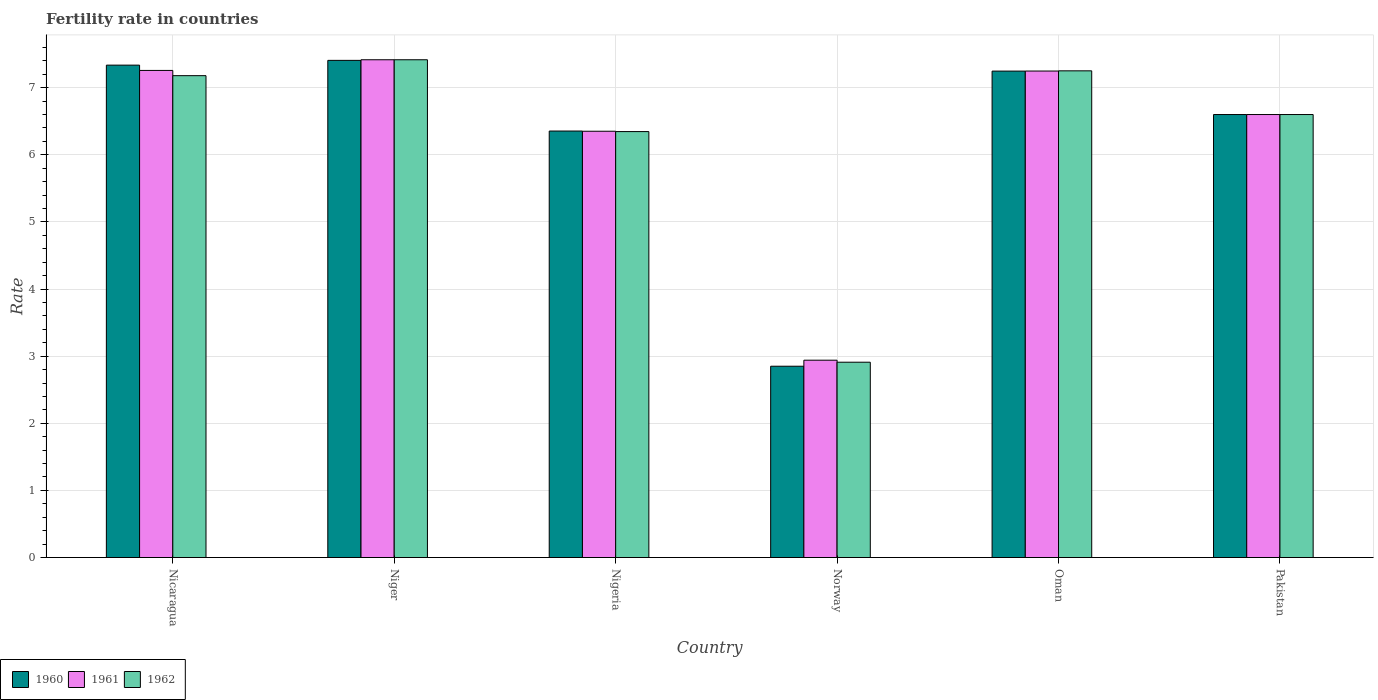How many groups of bars are there?
Make the answer very short. 6. Are the number of bars per tick equal to the number of legend labels?
Ensure brevity in your answer.  Yes. How many bars are there on the 2nd tick from the right?
Ensure brevity in your answer.  3. In how many cases, is the number of bars for a given country not equal to the number of legend labels?
Give a very brief answer. 0. What is the fertility rate in 1962 in Nigeria?
Your response must be concise. 6.35. Across all countries, what is the maximum fertility rate in 1962?
Provide a succinct answer. 7.42. Across all countries, what is the minimum fertility rate in 1961?
Provide a succinct answer. 2.94. In which country was the fertility rate in 1960 maximum?
Offer a very short reply. Niger. In which country was the fertility rate in 1960 minimum?
Your response must be concise. Norway. What is the total fertility rate in 1960 in the graph?
Your answer should be compact. 37.79. What is the difference between the fertility rate in 1961 in Niger and that in Pakistan?
Make the answer very short. 0.82. What is the difference between the fertility rate in 1961 in Norway and the fertility rate in 1960 in Oman?
Ensure brevity in your answer.  -4.31. What is the average fertility rate in 1960 per country?
Provide a succinct answer. 6.3. What is the difference between the fertility rate of/in 1960 and fertility rate of/in 1961 in Oman?
Make the answer very short. -0. In how many countries, is the fertility rate in 1961 greater than 5.6?
Provide a short and direct response. 5. What is the ratio of the fertility rate in 1961 in Norway to that in Oman?
Provide a short and direct response. 0.41. Is the difference between the fertility rate in 1960 in Nigeria and Pakistan greater than the difference between the fertility rate in 1961 in Nigeria and Pakistan?
Ensure brevity in your answer.  Yes. What is the difference between the highest and the second highest fertility rate in 1961?
Ensure brevity in your answer.  -0.01. What is the difference between the highest and the lowest fertility rate in 1961?
Give a very brief answer. 4.48. Is it the case that in every country, the sum of the fertility rate in 1960 and fertility rate in 1962 is greater than the fertility rate in 1961?
Make the answer very short. Yes. Are all the bars in the graph horizontal?
Your answer should be compact. No. What is the difference between two consecutive major ticks on the Y-axis?
Ensure brevity in your answer.  1. Are the values on the major ticks of Y-axis written in scientific E-notation?
Make the answer very short. No. Does the graph contain grids?
Offer a terse response. Yes. How many legend labels are there?
Your response must be concise. 3. How are the legend labels stacked?
Make the answer very short. Horizontal. What is the title of the graph?
Your response must be concise. Fertility rate in countries. What is the label or title of the X-axis?
Provide a succinct answer. Country. What is the label or title of the Y-axis?
Offer a very short reply. Rate. What is the Rate of 1960 in Nicaragua?
Provide a short and direct response. 7.34. What is the Rate in 1961 in Nicaragua?
Provide a short and direct response. 7.26. What is the Rate of 1962 in Nicaragua?
Provide a succinct answer. 7.18. What is the Rate of 1960 in Niger?
Your answer should be compact. 7.41. What is the Rate of 1961 in Niger?
Offer a very short reply. 7.42. What is the Rate in 1962 in Niger?
Give a very brief answer. 7.42. What is the Rate of 1960 in Nigeria?
Provide a short and direct response. 6.35. What is the Rate in 1961 in Nigeria?
Your answer should be very brief. 6.35. What is the Rate of 1962 in Nigeria?
Provide a succinct answer. 6.35. What is the Rate in 1960 in Norway?
Provide a short and direct response. 2.85. What is the Rate of 1961 in Norway?
Your answer should be very brief. 2.94. What is the Rate in 1962 in Norway?
Keep it short and to the point. 2.91. What is the Rate in 1960 in Oman?
Your answer should be very brief. 7.25. What is the Rate in 1961 in Oman?
Provide a short and direct response. 7.25. What is the Rate of 1962 in Oman?
Provide a succinct answer. 7.25. What is the Rate in 1960 in Pakistan?
Your response must be concise. 6.6. What is the Rate in 1961 in Pakistan?
Offer a very short reply. 6.6. Across all countries, what is the maximum Rate of 1960?
Give a very brief answer. 7.41. Across all countries, what is the maximum Rate of 1961?
Keep it short and to the point. 7.42. Across all countries, what is the maximum Rate in 1962?
Offer a very short reply. 7.42. Across all countries, what is the minimum Rate of 1960?
Provide a succinct answer. 2.85. Across all countries, what is the minimum Rate of 1961?
Ensure brevity in your answer.  2.94. Across all countries, what is the minimum Rate in 1962?
Give a very brief answer. 2.91. What is the total Rate of 1960 in the graph?
Offer a terse response. 37.79. What is the total Rate of 1961 in the graph?
Offer a very short reply. 37.81. What is the total Rate in 1962 in the graph?
Offer a terse response. 37.7. What is the difference between the Rate in 1960 in Nicaragua and that in Niger?
Your answer should be compact. -0.07. What is the difference between the Rate of 1961 in Nicaragua and that in Niger?
Keep it short and to the point. -0.16. What is the difference between the Rate in 1962 in Nicaragua and that in Niger?
Offer a terse response. -0.24. What is the difference between the Rate in 1960 in Nicaragua and that in Nigeria?
Keep it short and to the point. 0.98. What is the difference between the Rate in 1961 in Nicaragua and that in Nigeria?
Offer a very short reply. 0.91. What is the difference between the Rate in 1962 in Nicaragua and that in Nigeria?
Make the answer very short. 0.83. What is the difference between the Rate of 1960 in Nicaragua and that in Norway?
Ensure brevity in your answer.  4.49. What is the difference between the Rate in 1961 in Nicaragua and that in Norway?
Ensure brevity in your answer.  4.32. What is the difference between the Rate in 1962 in Nicaragua and that in Norway?
Your answer should be very brief. 4.27. What is the difference between the Rate of 1960 in Nicaragua and that in Oman?
Your answer should be compact. 0.09. What is the difference between the Rate of 1961 in Nicaragua and that in Oman?
Provide a succinct answer. 0.01. What is the difference between the Rate in 1962 in Nicaragua and that in Oman?
Your answer should be very brief. -0.07. What is the difference between the Rate in 1960 in Nicaragua and that in Pakistan?
Offer a terse response. 0.74. What is the difference between the Rate in 1961 in Nicaragua and that in Pakistan?
Your answer should be compact. 0.66. What is the difference between the Rate of 1962 in Nicaragua and that in Pakistan?
Your response must be concise. 0.58. What is the difference between the Rate in 1960 in Niger and that in Nigeria?
Offer a very short reply. 1.05. What is the difference between the Rate in 1961 in Niger and that in Nigeria?
Provide a short and direct response. 1.06. What is the difference between the Rate of 1962 in Niger and that in Nigeria?
Your answer should be very brief. 1.07. What is the difference between the Rate in 1960 in Niger and that in Norway?
Give a very brief answer. 4.56. What is the difference between the Rate in 1961 in Niger and that in Norway?
Provide a succinct answer. 4.48. What is the difference between the Rate of 1962 in Niger and that in Norway?
Provide a short and direct response. 4.51. What is the difference between the Rate in 1960 in Niger and that in Oman?
Your answer should be very brief. 0.16. What is the difference between the Rate of 1961 in Niger and that in Oman?
Offer a very short reply. 0.17. What is the difference between the Rate of 1962 in Niger and that in Oman?
Ensure brevity in your answer.  0.17. What is the difference between the Rate of 1960 in Niger and that in Pakistan?
Make the answer very short. 0.81. What is the difference between the Rate in 1961 in Niger and that in Pakistan?
Provide a succinct answer. 0.82. What is the difference between the Rate of 1962 in Niger and that in Pakistan?
Your answer should be very brief. 0.82. What is the difference between the Rate in 1960 in Nigeria and that in Norway?
Provide a succinct answer. 3.5. What is the difference between the Rate in 1961 in Nigeria and that in Norway?
Ensure brevity in your answer.  3.41. What is the difference between the Rate in 1962 in Nigeria and that in Norway?
Ensure brevity in your answer.  3.44. What is the difference between the Rate in 1960 in Nigeria and that in Oman?
Provide a short and direct response. -0.89. What is the difference between the Rate in 1961 in Nigeria and that in Oman?
Your response must be concise. -0.9. What is the difference between the Rate of 1962 in Nigeria and that in Oman?
Offer a terse response. -0.91. What is the difference between the Rate in 1960 in Nigeria and that in Pakistan?
Your answer should be compact. -0.25. What is the difference between the Rate of 1961 in Nigeria and that in Pakistan?
Make the answer very short. -0.25. What is the difference between the Rate of 1962 in Nigeria and that in Pakistan?
Your response must be concise. -0.25. What is the difference between the Rate in 1960 in Norway and that in Oman?
Ensure brevity in your answer.  -4.4. What is the difference between the Rate in 1961 in Norway and that in Oman?
Provide a succinct answer. -4.31. What is the difference between the Rate in 1962 in Norway and that in Oman?
Keep it short and to the point. -4.34. What is the difference between the Rate of 1960 in Norway and that in Pakistan?
Offer a terse response. -3.75. What is the difference between the Rate of 1961 in Norway and that in Pakistan?
Make the answer very short. -3.66. What is the difference between the Rate in 1962 in Norway and that in Pakistan?
Provide a short and direct response. -3.69. What is the difference between the Rate in 1960 in Oman and that in Pakistan?
Give a very brief answer. 0.65. What is the difference between the Rate in 1961 in Oman and that in Pakistan?
Ensure brevity in your answer.  0.65. What is the difference between the Rate of 1962 in Oman and that in Pakistan?
Provide a succinct answer. 0.65. What is the difference between the Rate in 1960 in Nicaragua and the Rate in 1961 in Niger?
Offer a very short reply. -0.08. What is the difference between the Rate of 1960 in Nicaragua and the Rate of 1962 in Niger?
Your answer should be very brief. -0.08. What is the difference between the Rate of 1961 in Nicaragua and the Rate of 1962 in Niger?
Provide a succinct answer. -0.16. What is the difference between the Rate of 1960 in Nicaragua and the Rate of 1961 in Nigeria?
Keep it short and to the point. 0.98. What is the difference between the Rate in 1961 in Nicaragua and the Rate in 1962 in Nigeria?
Give a very brief answer. 0.91. What is the difference between the Rate in 1960 in Nicaragua and the Rate in 1961 in Norway?
Offer a terse response. 4.4. What is the difference between the Rate in 1960 in Nicaragua and the Rate in 1962 in Norway?
Offer a terse response. 4.43. What is the difference between the Rate in 1961 in Nicaragua and the Rate in 1962 in Norway?
Provide a succinct answer. 4.35. What is the difference between the Rate in 1960 in Nicaragua and the Rate in 1961 in Oman?
Ensure brevity in your answer.  0.09. What is the difference between the Rate of 1960 in Nicaragua and the Rate of 1962 in Oman?
Your answer should be very brief. 0.09. What is the difference between the Rate of 1961 in Nicaragua and the Rate of 1962 in Oman?
Your answer should be very brief. 0.01. What is the difference between the Rate in 1960 in Nicaragua and the Rate in 1961 in Pakistan?
Offer a terse response. 0.74. What is the difference between the Rate in 1960 in Nicaragua and the Rate in 1962 in Pakistan?
Offer a very short reply. 0.74. What is the difference between the Rate in 1961 in Nicaragua and the Rate in 1962 in Pakistan?
Your response must be concise. 0.66. What is the difference between the Rate of 1960 in Niger and the Rate of 1961 in Nigeria?
Provide a short and direct response. 1.06. What is the difference between the Rate in 1960 in Niger and the Rate in 1962 in Nigeria?
Your answer should be very brief. 1.06. What is the difference between the Rate in 1961 in Niger and the Rate in 1962 in Nigeria?
Your answer should be compact. 1.07. What is the difference between the Rate of 1960 in Niger and the Rate of 1961 in Norway?
Give a very brief answer. 4.47. What is the difference between the Rate of 1960 in Niger and the Rate of 1962 in Norway?
Make the answer very short. 4.5. What is the difference between the Rate of 1961 in Niger and the Rate of 1962 in Norway?
Your response must be concise. 4.51. What is the difference between the Rate in 1960 in Niger and the Rate in 1961 in Oman?
Provide a succinct answer. 0.16. What is the difference between the Rate in 1960 in Niger and the Rate in 1962 in Oman?
Provide a short and direct response. 0.16. What is the difference between the Rate of 1961 in Niger and the Rate of 1962 in Oman?
Keep it short and to the point. 0.17. What is the difference between the Rate in 1960 in Niger and the Rate in 1961 in Pakistan?
Keep it short and to the point. 0.81. What is the difference between the Rate of 1960 in Niger and the Rate of 1962 in Pakistan?
Keep it short and to the point. 0.81. What is the difference between the Rate in 1961 in Niger and the Rate in 1962 in Pakistan?
Give a very brief answer. 0.82. What is the difference between the Rate of 1960 in Nigeria and the Rate of 1961 in Norway?
Offer a terse response. 3.41. What is the difference between the Rate in 1960 in Nigeria and the Rate in 1962 in Norway?
Give a very brief answer. 3.44. What is the difference between the Rate in 1961 in Nigeria and the Rate in 1962 in Norway?
Your answer should be very brief. 3.44. What is the difference between the Rate in 1960 in Nigeria and the Rate in 1961 in Oman?
Your answer should be compact. -0.89. What is the difference between the Rate of 1960 in Nigeria and the Rate of 1962 in Oman?
Your answer should be compact. -0.9. What is the difference between the Rate in 1960 in Nigeria and the Rate in 1961 in Pakistan?
Offer a terse response. -0.25. What is the difference between the Rate of 1960 in Nigeria and the Rate of 1962 in Pakistan?
Offer a terse response. -0.25. What is the difference between the Rate in 1961 in Nigeria and the Rate in 1962 in Pakistan?
Provide a succinct answer. -0.25. What is the difference between the Rate of 1960 in Norway and the Rate of 1961 in Oman?
Ensure brevity in your answer.  -4.4. What is the difference between the Rate of 1960 in Norway and the Rate of 1962 in Oman?
Keep it short and to the point. -4.4. What is the difference between the Rate in 1961 in Norway and the Rate in 1962 in Oman?
Ensure brevity in your answer.  -4.31. What is the difference between the Rate of 1960 in Norway and the Rate of 1961 in Pakistan?
Offer a terse response. -3.75. What is the difference between the Rate of 1960 in Norway and the Rate of 1962 in Pakistan?
Ensure brevity in your answer.  -3.75. What is the difference between the Rate of 1961 in Norway and the Rate of 1962 in Pakistan?
Keep it short and to the point. -3.66. What is the difference between the Rate in 1960 in Oman and the Rate in 1961 in Pakistan?
Offer a very short reply. 0.65. What is the difference between the Rate in 1960 in Oman and the Rate in 1962 in Pakistan?
Offer a very short reply. 0.65. What is the difference between the Rate of 1961 in Oman and the Rate of 1962 in Pakistan?
Your answer should be very brief. 0.65. What is the average Rate in 1960 per country?
Provide a short and direct response. 6.3. What is the average Rate in 1961 per country?
Provide a succinct answer. 6.3. What is the average Rate of 1962 per country?
Give a very brief answer. 6.28. What is the difference between the Rate in 1960 and Rate in 1961 in Nicaragua?
Provide a succinct answer. 0.08. What is the difference between the Rate in 1960 and Rate in 1962 in Nicaragua?
Keep it short and to the point. 0.16. What is the difference between the Rate of 1961 and Rate of 1962 in Nicaragua?
Ensure brevity in your answer.  0.08. What is the difference between the Rate of 1960 and Rate of 1961 in Niger?
Give a very brief answer. -0.01. What is the difference between the Rate of 1960 and Rate of 1962 in Niger?
Make the answer very short. -0.01. What is the difference between the Rate of 1960 and Rate of 1961 in Nigeria?
Your answer should be compact. 0. What is the difference between the Rate of 1960 and Rate of 1962 in Nigeria?
Provide a succinct answer. 0.01. What is the difference between the Rate in 1961 and Rate in 1962 in Nigeria?
Keep it short and to the point. 0.01. What is the difference between the Rate of 1960 and Rate of 1961 in Norway?
Offer a terse response. -0.09. What is the difference between the Rate of 1960 and Rate of 1962 in Norway?
Ensure brevity in your answer.  -0.06. What is the difference between the Rate of 1960 and Rate of 1961 in Oman?
Offer a very short reply. -0. What is the difference between the Rate in 1960 and Rate in 1962 in Oman?
Offer a terse response. -0. What is the difference between the Rate in 1961 and Rate in 1962 in Oman?
Give a very brief answer. -0. What is the difference between the Rate in 1960 and Rate in 1961 in Pakistan?
Keep it short and to the point. 0. What is the difference between the Rate of 1960 and Rate of 1962 in Pakistan?
Your response must be concise. 0. What is the difference between the Rate of 1961 and Rate of 1962 in Pakistan?
Make the answer very short. 0. What is the ratio of the Rate of 1960 in Nicaragua to that in Niger?
Offer a terse response. 0.99. What is the ratio of the Rate of 1961 in Nicaragua to that in Niger?
Provide a succinct answer. 0.98. What is the ratio of the Rate in 1960 in Nicaragua to that in Nigeria?
Ensure brevity in your answer.  1.15. What is the ratio of the Rate in 1961 in Nicaragua to that in Nigeria?
Give a very brief answer. 1.14. What is the ratio of the Rate in 1962 in Nicaragua to that in Nigeria?
Offer a very short reply. 1.13. What is the ratio of the Rate of 1960 in Nicaragua to that in Norway?
Your answer should be very brief. 2.57. What is the ratio of the Rate in 1961 in Nicaragua to that in Norway?
Keep it short and to the point. 2.47. What is the ratio of the Rate of 1962 in Nicaragua to that in Norway?
Offer a terse response. 2.47. What is the ratio of the Rate in 1960 in Nicaragua to that in Oman?
Your response must be concise. 1.01. What is the ratio of the Rate in 1961 in Nicaragua to that in Oman?
Offer a very short reply. 1. What is the ratio of the Rate of 1960 in Nicaragua to that in Pakistan?
Provide a short and direct response. 1.11. What is the ratio of the Rate in 1961 in Nicaragua to that in Pakistan?
Keep it short and to the point. 1.1. What is the ratio of the Rate of 1962 in Nicaragua to that in Pakistan?
Offer a terse response. 1.09. What is the ratio of the Rate of 1960 in Niger to that in Nigeria?
Provide a succinct answer. 1.17. What is the ratio of the Rate in 1961 in Niger to that in Nigeria?
Your answer should be compact. 1.17. What is the ratio of the Rate in 1962 in Niger to that in Nigeria?
Your answer should be compact. 1.17. What is the ratio of the Rate of 1960 in Niger to that in Norway?
Your answer should be compact. 2.6. What is the ratio of the Rate in 1961 in Niger to that in Norway?
Ensure brevity in your answer.  2.52. What is the ratio of the Rate in 1962 in Niger to that in Norway?
Your answer should be compact. 2.55. What is the ratio of the Rate in 1960 in Niger to that in Oman?
Offer a terse response. 1.02. What is the ratio of the Rate of 1961 in Niger to that in Oman?
Provide a short and direct response. 1.02. What is the ratio of the Rate of 1962 in Niger to that in Oman?
Ensure brevity in your answer.  1.02. What is the ratio of the Rate in 1960 in Niger to that in Pakistan?
Make the answer very short. 1.12. What is the ratio of the Rate in 1961 in Niger to that in Pakistan?
Offer a terse response. 1.12. What is the ratio of the Rate in 1962 in Niger to that in Pakistan?
Offer a very short reply. 1.12. What is the ratio of the Rate of 1960 in Nigeria to that in Norway?
Your response must be concise. 2.23. What is the ratio of the Rate of 1961 in Nigeria to that in Norway?
Offer a terse response. 2.16. What is the ratio of the Rate of 1962 in Nigeria to that in Norway?
Your answer should be compact. 2.18. What is the ratio of the Rate in 1960 in Nigeria to that in Oman?
Give a very brief answer. 0.88. What is the ratio of the Rate of 1961 in Nigeria to that in Oman?
Offer a terse response. 0.88. What is the ratio of the Rate of 1962 in Nigeria to that in Oman?
Ensure brevity in your answer.  0.88. What is the ratio of the Rate of 1960 in Nigeria to that in Pakistan?
Your answer should be very brief. 0.96. What is the ratio of the Rate in 1961 in Nigeria to that in Pakistan?
Ensure brevity in your answer.  0.96. What is the ratio of the Rate in 1962 in Nigeria to that in Pakistan?
Offer a very short reply. 0.96. What is the ratio of the Rate in 1960 in Norway to that in Oman?
Your answer should be compact. 0.39. What is the ratio of the Rate in 1961 in Norway to that in Oman?
Provide a short and direct response. 0.41. What is the ratio of the Rate of 1962 in Norway to that in Oman?
Provide a short and direct response. 0.4. What is the ratio of the Rate in 1960 in Norway to that in Pakistan?
Offer a very short reply. 0.43. What is the ratio of the Rate of 1961 in Norway to that in Pakistan?
Your answer should be compact. 0.45. What is the ratio of the Rate of 1962 in Norway to that in Pakistan?
Provide a succinct answer. 0.44. What is the ratio of the Rate in 1960 in Oman to that in Pakistan?
Offer a terse response. 1.1. What is the ratio of the Rate in 1961 in Oman to that in Pakistan?
Provide a succinct answer. 1.1. What is the ratio of the Rate of 1962 in Oman to that in Pakistan?
Your answer should be very brief. 1.1. What is the difference between the highest and the second highest Rate of 1960?
Offer a very short reply. 0.07. What is the difference between the highest and the second highest Rate in 1961?
Provide a succinct answer. 0.16. What is the difference between the highest and the second highest Rate in 1962?
Your answer should be compact. 0.17. What is the difference between the highest and the lowest Rate of 1960?
Give a very brief answer. 4.56. What is the difference between the highest and the lowest Rate in 1961?
Make the answer very short. 4.48. What is the difference between the highest and the lowest Rate of 1962?
Make the answer very short. 4.51. 